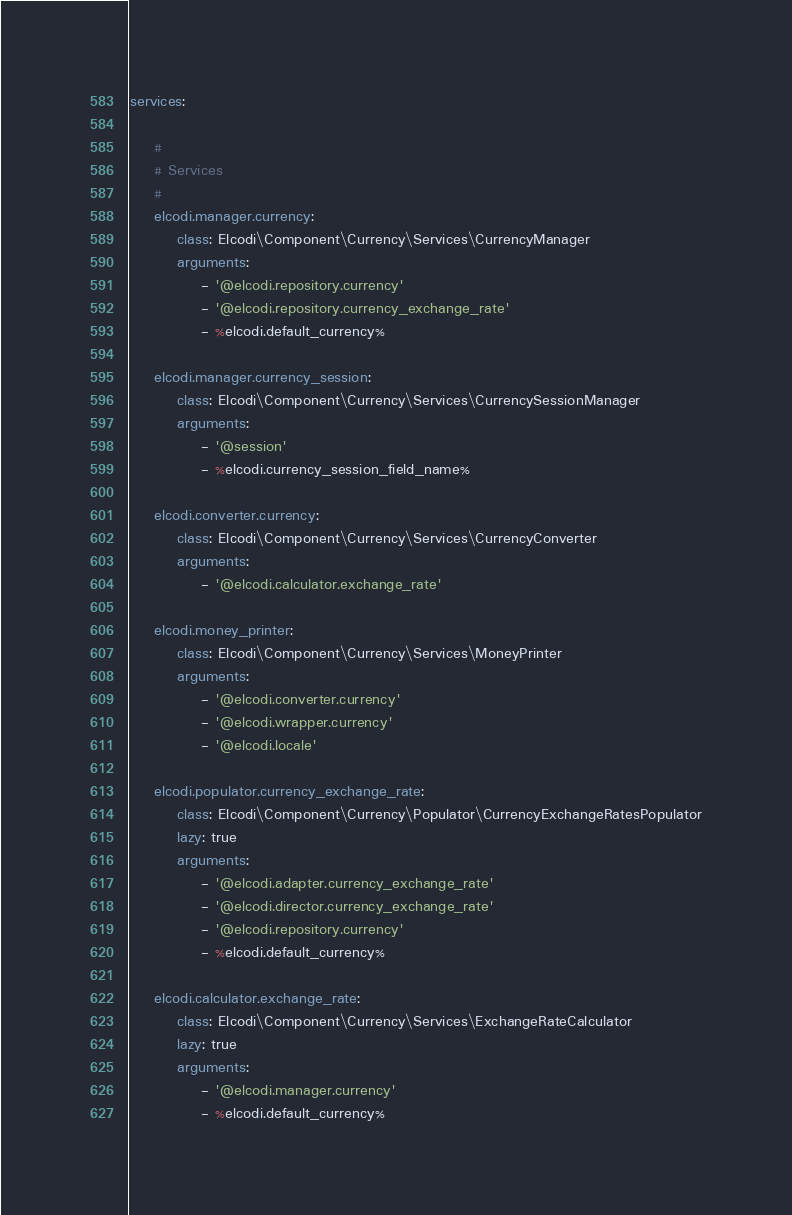Convert code to text. <code><loc_0><loc_0><loc_500><loc_500><_YAML_>services:

    #
    # Services
    #
    elcodi.manager.currency:
        class: Elcodi\Component\Currency\Services\CurrencyManager
        arguments:
            - '@elcodi.repository.currency'
            - '@elcodi.repository.currency_exchange_rate'
            - %elcodi.default_currency%

    elcodi.manager.currency_session:
        class: Elcodi\Component\Currency\Services\CurrencySessionManager
        arguments:
            - '@session'
            - %elcodi.currency_session_field_name%

    elcodi.converter.currency:
        class: Elcodi\Component\Currency\Services\CurrencyConverter
        arguments:
            - '@elcodi.calculator.exchange_rate'

    elcodi.money_printer:
        class: Elcodi\Component\Currency\Services\MoneyPrinter
        arguments:
            - '@elcodi.converter.currency'
            - '@elcodi.wrapper.currency'
            - '@elcodi.locale'

    elcodi.populator.currency_exchange_rate:
        class: Elcodi\Component\Currency\Populator\CurrencyExchangeRatesPopulator
        lazy: true
        arguments:
            - '@elcodi.adapter.currency_exchange_rate'
            - '@elcodi.director.currency_exchange_rate'
            - '@elcodi.repository.currency'
            - %elcodi.default_currency%

    elcodi.calculator.exchange_rate:
        class: Elcodi\Component\Currency\Services\ExchangeRateCalculator
        lazy: true
        arguments:
            - '@elcodi.manager.currency'
            - %elcodi.default_currency%
</code> 